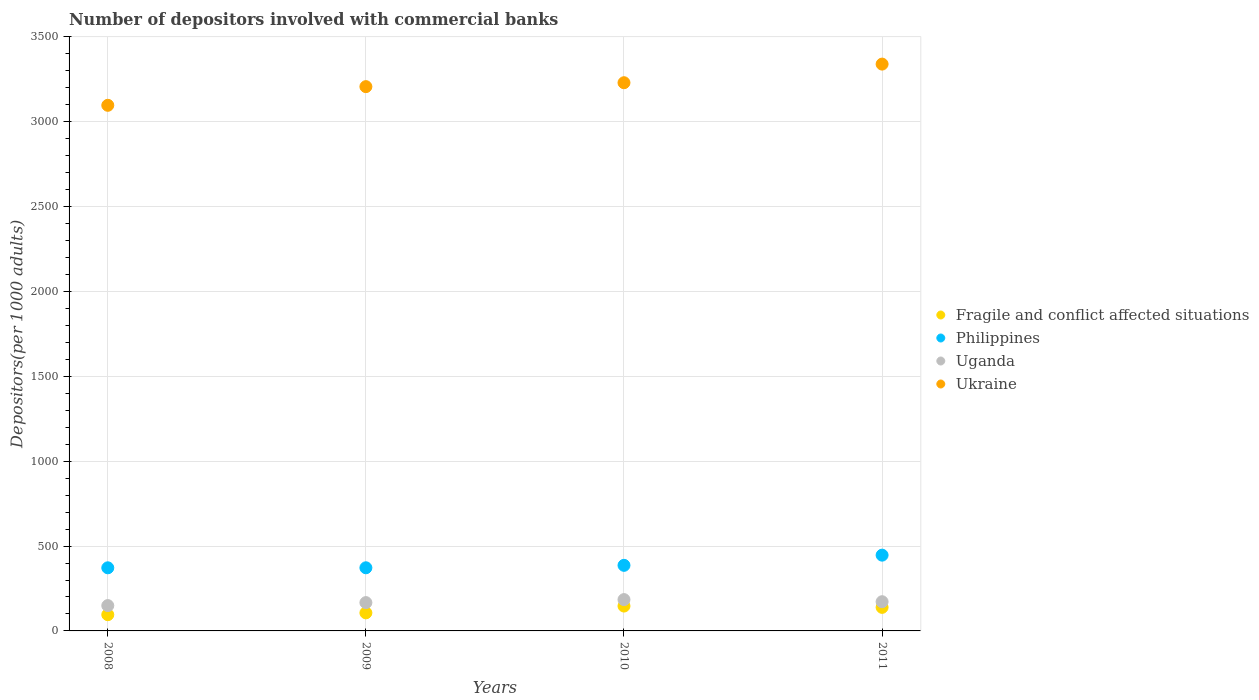How many different coloured dotlines are there?
Offer a terse response. 4. Is the number of dotlines equal to the number of legend labels?
Keep it short and to the point. Yes. What is the number of depositors involved with commercial banks in Philippines in 2010?
Make the answer very short. 386.38. Across all years, what is the maximum number of depositors involved with commercial banks in Fragile and conflict affected situations?
Keep it short and to the point. 146.5. Across all years, what is the minimum number of depositors involved with commercial banks in Uganda?
Offer a very short reply. 149.22. In which year was the number of depositors involved with commercial banks in Ukraine maximum?
Ensure brevity in your answer.  2011. What is the total number of depositors involved with commercial banks in Fragile and conflict affected situations in the graph?
Make the answer very short. 487.3. What is the difference between the number of depositors involved with commercial banks in Ukraine in 2008 and that in 2010?
Keep it short and to the point. -133.02. What is the difference between the number of depositors involved with commercial banks in Ukraine in 2011 and the number of depositors involved with commercial banks in Philippines in 2010?
Offer a terse response. 2953.02. What is the average number of depositors involved with commercial banks in Philippines per year?
Provide a succinct answer. 394.14. In the year 2010, what is the difference between the number of depositors involved with commercial banks in Uganda and number of depositors involved with commercial banks in Ukraine?
Ensure brevity in your answer.  -3045.11. What is the ratio of the number of depositors involved with commercial banks in Fragile and conflict affected situations in 2008 to that in 2011?
Ensure brevity in your answer.  0.69. What is the difference between the highest and the second highest number of depositors involved with commercial banks in Philippines?
Your answer should be very brief. 60.02. What is the difference between the highest and the lowest number of depositors involved with commercial banks in Fragile and conflict affected situations?
Your response must be concise. 50.84. In how many years, is the number of depositors involved with commercial banks in Fragile and conflict affected situations greater than the average number of depositors involved with commercial banks in Fragile and conflict affected situations taken over all years?
Your answer should be compact. 2. Is it the case that in every year, the sum of the number of depositors involved with commercial banks in Philippines and number of depositors involved with commercial banks in Uganda  is greater than the number of depositors involved with commercial banks in Fragile and conflict affected situations?
Provide a short and direct response. Yes. Is the number of depositors involved with commercial banks in Fragile and conflict affected situations strictly greater than the number of depositors involved with commercial banks in Philippines over the years?
Your response must be concise. No. How many dotlines are there?
Your answer should be very brief. 4. What is the difference between two consecutive major ticks on the Y-axis?
Offer a terse response. 500. Are the values on the major ticks of Y-axis written in scientific E-notation?
Your answer should be compact. No. Where does the legend appear in the graph?
Provide a succinct answer. Center right. What is the title of the graph?
Provide a succinct answer. Number of depositors involved with commercial banks. What is the label or title of the X-axis?
Offer a terse response. Years. What is the label or title of the Y-axis?
Give a very brief answer. Depositors(per 1000 adults). What is the Depositors(per 1000 adults) in Fragile and conflict affected situations in 2008?
Your answer should be compact. 95.65. What is the Depositors(per 1000 adults) of Philippines in 2008?
Provide a short and direct response. 371.81. What is the Depositors(per 1000 adults) in Uganda in 2008?
Give a very brief answer. 149.22. What is the Depositors(per 1000 adults) in Ukraine in 2008?
Offer a very short reply. 3096.67. What is the Depositors(per 1000 adults) in Fragile and conflict affected situations in 2009?
Your answer should be compact. 106.41. What is the Depositors(per 1000 adults) of Philippines in 2009?
Provide a short and direct response. 371.98. What is the Depositors(per 1000 adults) in Uganda in 2009?
Your answer should be compact. 166.83. What is the Depositors(per 1000 adults) in Ukraine in 2009?
Your response must be concise. 3206.64. What is the Depositors(per 1000 adults) of Fragile and conflict affected situations in 2010?
Your answer should be compact. 146.5. What is the Depositors(per 1000 adults) of Philippines in 2010?
Give a very brief answer. 386.38. What is the Depositors(per 1000 adults) in Uganda in 2010?
Offer a terse response. 184.58. What is the Depositors(per 1000 adults) of Ukraine in 2010?
Keep it short and to the point. 3229.69. What is the Depositors(per 1000 adults) in Fragile and conflict affected situations in 2011?
Offer a very short reply. 138.74. What is the Depositors(per 1000 adults) of Philippines in 2011?
Ensure brevity in your answer.  446.4. What is the Depositors(per 1000 adults) of Uganda in 2011?
Provide a succinct answer. 172.11. What is the Depositors(per 1000 adults) of Ukraine in 2011?
Provide a succinct answer. 3339.41. Across all years, what is the maximum Depositors(per 1000 adults) in Fragile and conflict affected situations?
Make the answer very short. 146.5. Across all years, what is the maximum Depositors(per 1000 adults) in Philippines?
Keep it short and to the point. 446.4. Across all years, what is the maximum Depositors(per 1000 adults) of Uganda?
Give a very brief answer. 184.58. Across all years, what is the maximum Depositors(per 1000 adults) of Ukraine?
Offer a terse response. 3339.41. Across all years, what is the minimum Depositors(per 1000 adults) in Fragile and conflict affected situations?
Your answer should be very brief. 95.65. Across all years, what is the minimum Depositors(per 1000 adults) of Philippines?
Offer a terse response. 371.81. Across all years, what is the minimum Depositors(per 1000 adults) in Uganda?
Provide a short and direct response. 149.22. Across all years, what is the minimum Depositors(per 1000 adults) in Ukraine?
Your answer should be very brief. 3096.67. What is the total Depositors(per 1000 adults) in Fragile and conflict affected situations in the graph?
Offer a terse response. 487.3. What is the total Depositors(per 1000 adults) of Philippines in the graph?
Keep it short and to the point. 1576.57. What is the total Depositors(per 1000 adults) in Uganda in the graph?
Your response must be concise. 672.74. What is the total Depositors(per 1000 adults) in Ukraine in the graph?
Your answer should be compact. 1.29e+04. What is the difference between the Depositors(per 1000 adults) of Fragile and conflict affected situations in 2008 and that in 2009?
Ensure brevity in your answer.  -10.75. What is the difference between the Depositors(per 1000 adults) of Philippines in 2008 and that in 2009?
Offer a very short reply. -0.17. What is the difference between the Depositors(per 1000 adults) in Uganda in 2008 and that in 2009?
Offer a very short reply. -17.61. What is the difference between the Depositors(per 1000 adults) of Ukraine in 2008 and that in 2009?
Your response must be concise. -109.97. What is the difference between the Depositors(per 1000 adults) in Fragile and conflict affected situations in 2008 and that in 2010?
Ensure brevity in your answer.  -50.84. What is the difference between the Depositors(per 1000 adults) of Philippines in 2008 and that in 2010?
Offer a terse response. -14.57. What is the difference between the Depositors(per 1000 adults) in Uganda in 2008 and that in 2010?
Provide a short and direct response. -35.36. What is the difference between the Depositors(per 1000 adults) of Ukraine in 2008 and that in 2010?
Your answer should be very brief. -133.02. What is the difference between the Depositors(per 1000 adults) in Fragile and conflict affected situations in 2008 and that in 2011?
Your answer should be very brief. -43.09. What is the difference between the Depositors(per 1000 adults) of Philippines in 2008 and that in 2011?
Keep it short and to the point. -74.59. What is the difference between the Depositors(per 1000 adults) in Uganda in 2008 and that in 2011?
Your response must be concise. -22.89. What is the difference between the Depositors(per 1000 adults) of Ukraine in 2008 and that in 2011?
Your answer should be very brief. -242.74. What is the difference between the Depositors(per 1000 adults) of Fragile and conflict affected situations in 2009 and that in 2010?
Your answer should be very brief. -40.09. What is the difference between the Depositors(per 1000 adults) of Philippines in 2009 and that in 2010?
Provide a short and direct response. -14.4. What is the difference between the Depositors(per 1000 adults) of Uganda in 2009 and that in 2010?
Offer a very short reply. -17.75. What is the difference between the Depositors(per 1000 adults) in Ukraine in 2009 and that in 2010?
Offer a very short reply. -23.06. What is the difference between the Depositors(per 1000 adults) of Fragile and conflict affected situations in 2009 and that in 2011?
Ensure brevity in your answer.  -32.34. What is the difference between the Depositors(per 1000 adults) in Philippines in 2009 and that in 2011?
Ensure brevity in your answer.  -74.42. What is the difference between the Depositors(per 1000 adults) in Uganda in 2009 and that in 2011?
Your response must be concise. -5.28. What is the difference between the Depositors(per 1000 adults) in Ukraine in 2009 and that in 2011?
Make the answer very short. -132.77. What is the difference between the Depositors(per 1000 adults) of Fragile and conflict affected situations in 2010 and that in 2011?
Offer a terse response. 7.75. What is the difference between the Depositors(per 1000 adults) in Philippines in 2010 and that in 2011?
Offer a terse response. -60.02. What is the difference between the Depositors(per 1000 adults) of Uganda in 2010 and that in 2011?
Offer a terse response. 12.47. What is the difference between the Depositors(per 1000 adults) of Ukraine in 2010 and that in 2011?
Give a very brief answer. -109.71. What is the difference between the Depositors(per 1000 adults) of Fragile and conflict affected situations in 2008 and the Depositors(per 1000 adults) of Philippines in 2009?
Ensure brevity in your answer.  -276.33. What is the difference between the Depositors(per 1000 adults) in Fragile and conflict affected situations in 2008 and the Depositors(per 1000 adults) in Uganda in 2009?
Give a very brief answer. -71.18. What is the difference between the Depositors(per 1000 adults) in Fragile and conflict affected situations in 2008 and the Depositors(per 1000 adults) in Ukraine in 2009?
Provide a succinct answer. -3110.99. What is the difference between the Depositors(per 1000 adults) of Philippines in 2008 and the Depositors(per 1000 adults) of Uganda in 2009?
Keep it short and to the point. 204.98. What is the difference between the Depositors(per 1000 adults) of Philippines in 2008 and the Depositors(per 1000 adults) of Ukraine in 2009?
Make the answer very short. -2834.83. What is the difference between the Depositors(per 1000 adults) in Uganda in 2008 and the Depositors(per 1000 adults) in Ukraine in 2009?
Provide a succinct answer. -3057.42. What is the difference between the Depositors(per 1000 adults) of Fragile and conflict affected situations in 2008 and the Depositors(per 1000 adults) of Philippines in 2010?
Offer a terse response. -290.73. What is the difference between the Depositors(per 1000 adults) of Fragile and conflict affected situations in 2008 and the Depositors(per 1000 adults) of Uganda in 2010?
Offer a terse response. -88.93. What is the difference between the Depositors(per 1000 adults) in Fragile and conflict affected situations in 2008 and the Depositors(per 1000 adults) in Ukraine in 2010?
Keep it short and to the point. -3134.04. What is the difference between the Depositors(per 1000 adults) in Philippines in 2008 and the Depositors(per 1000 adults) in Uganda in 2010?
Make the answer very short. 187.23. What is the difference between the Depositors(per 1000 adults) in Philippines in 2008 and the Depositors(per 1000 adults) in Ukraine in 2010?
Provide a short and direct response. -2857.88. What is the difference between the Depositors(per 1000 adults) of Uganda in 2008 and the Depositors(per 1000 adults) of Ukraine in 2010?
Your answer should be compact. -3080.47. What is the difference between the Depositors(per 1000 adults) in Fragile and conflict affected situations in 2008 and the Depositors(per 1000 adults) in Philippines in 2011?
Make the answer very short. -350.75. What is the difference between the Depositors(per 1000 adults) of Fragile and conflict affected situations in 2008 and the Depositors(per 1000 adults) of Uganda in 2011?
Your answer should be very brief. -76.45. What is the difference between the Depositors(per 1000 adults) in Fragile and conflict affected situations in 2008 and the Depositors(per 1000 adults) in Ukraine in 2011?
Give a very brief answer. -3243.75. What is the difference between the Depositors(per 1000 adults) of Philippines in 2008 and the Depositors(per 1000 adults) of Uganda in 2011?
Your answer should be compact. 199.7. What is the difference between the Depositors(per 1000 adults) of Philippines in 2008 and the Depositors(per 1000 adults) of Ukraine in 2011?
Offer a terse response. -2967.59. What is the difference between the Depositors(per 1000 adults) of Uganda in 2008 and the Depositors(per 1000 adults) of Ukraine in 2011?
Provide a succinct answer. -3190.19. What is the difference between the Depositors(per 1000 adults) of Fragile and conflict affected situations in 2009 and the Depositors(per 1000 adults) of Philippines in 2010?
Provide a short and direct response. -279.98. What is the difference between the Depositors(per 1000 adults) of Fragile and conflict affected situations in 2009 and the Depositors(per 1000 adults) of Uganda in 2010?
Your response must be concise. -78.17. What is the difference between the Depositors(per 1000 adults) in Fragile and conflict affected situations in 2009 and the Depositors(per 1000 adults) in Ukraine in 2010?
Provide a succinct answer. -3123.29. What is the difference between the Depositors(per 1000 adults) of Philippines in 2009 and the Depositors(per 1000 adults) of Uganda in 2010?
Ensure brevity in your answer.  187.4. What is the difference between the Depositors(per 1000 adults) of Philippines in 2009 and the Depositors(per 1000 adults) of Ukraine in 2010?
Make the answer very short. -2857.71. What is the difference between the Depositors(per 1000 adults) of Uganda in 2009 and the Depositors(per 1000 adults) of Ukraine in 2010?
Provide a succinct answer. -3062.86. What is the difference between the Depositors(per 1000 adults) of Fragile and conflict affected situations in 2009 and the Depositors(per 1000 adults) of Philippines in 2011?
Keep it short and to the point. -339.99. What is the difference between the Depositors(per 1000 adults) of Fragile and conflict affected situations in 2009 and the Depositors(per 1000 adults) of Uganda in 2011?
Offer a very short reply. -65.7. What is the difference between the Depositors(per 1000 adults) of Fragile and conflict affected situations in 2009 and the Depositors(per 1000 adults) of Ukraine in 2011?
Make the answer very short. -3233. What is the difference between the Depositors(per 1000 adults) in Philippines in 2009 and the Depositors(per 1000 adults) in Uganda in 2011?
Provide a succinct answer. 199.87. What is the difference between the Depositors(per 1000 adults) of Philippines in 2009 and the Depositors(per 1000 adults) of Ukraine in 2011?
Give a very brief answer. -2967.43. What is the difference between the Depositors(per 1000 adults) in Uganda in 2009 and the Depositors(per 1000 adults) in Ukraine in 2011?
Provide a short and direct response. -3172.58. What is the difference between the Depositors(per 1000 adults) of Fragile and conflict affected situations in 2010 and the Depositors(per 1000 adults) of Philippines in 2011?
Your answer should be very brief. -299.9. What is the difference between the Depositors(per 1000 adults) in Fragile and conflict affected situations in 2010 and the Depositors(per 1000 adults) in Uganda in 2011?
Ensure brevity in your answer.  -25.61. What is the difference between the Depositors(per 1000 adults) of Fragile and conflict affected situations in 2010 and the Depositors(per 1000 adults) of Ukraine in 2011?
Offer a terse response. -3192.91. What is the difference between the Depositors(per 1000 adults) in Philippines in 2010 and the Depositors(per 1000 adults) in Uganda in 2011?
Offer a terse response. 214.28. What is the difference between the Depositors(per 1000 adults) of Philippines in 2010 and the Depositors(per 1000 adults) of Ukraine in 2011?
Make the answer very short. -2953.02. What is the difference between the Depositors(per 1000 adults) of Uganda in 2010 and the Depositors(per 1000 adults) of Ukraine in 2011?
Provide a succinct answer. -3154.83. What is the average Depositors(per 1000 adults) in Fragile and conflict affected situations per year?
Provide a short and direct response. 121.82. What is the average Depositors(per 1000 adults) of Philippines per year?
Your answer should be very brief. 394.14. What is the average Depositors(per 1000 adults) of Uganda per year?
Your answer should be compact. 168.18. What is the average Depositors(per 1000 adults) of Ukraine per year?
Your answer should be compact. 3218.1. In the year 2008, what is the difference between the Depositors(per 1000 adults) in Fragile and conflict affected situations and Depositors(per 1000 adults) in Philippines?
Offer a very short reply. -276.16. In the year 2008, what is the difference between the Depositors(per 1000 adults) in Fragile and conflict affected situations and Depositors(per 1000 adults) in Uganda?
Offer a very short reply. -53.57. In the year 2008, what is the difference between the Depositors(per 1000 adults) in Fragile and conflict affected situations and Depositors(per 1000 adults) in Ukraine?
Ensure brevity in your answer.  -3001.02. In the year 2008, what is the difference between the Depositors(per 1000 adults) of Philippines and Depositors(per 1000 adults) of Uganda?
Your response must be concise. 222.59. In the year 2008, what is the difference between the Depositors(per 1000 adults) of Philippines and Depositors(per 1000 adults) of Ukraine?
Give a very brief answer. -2724.86. In the year 2008, what is the difference between the Depositors(per 1000 adults) in Uganda and Depositors(per 1000 adults) in Ukraine?
Provide a succinct answer. -2947.45. In the year 2009, what is the difference between the Depositors(per 1000 adults) in Fragile and conflict affected situations and Depositors(per 1000 adults) in Philippines?
Make the answer very short. -265.57. In the year 2009, what is the difference between the Depositors(per 1000 adults) in Fragile and conflict affected situations and Depositors(per 1000 adults) in Uganda?
Your answer should be compact. -60.42. In the year 2009, what is the difference between the Depositors(per 1000 adults) of Fragile and conflict affected situations and Depositors(per 1000 adults) of Ukraine?
Make the answer very short. -3100.23. In the year 2009, what is the difference between the Depositors(per 1000 adults) of Philippines and Depositors(per 1000 adults) of Uganda?
Give a very brief answer. 205.15. In the year 2009, what is the difference between the Depositors(per 1000 adults) of Philippines and Depositors(per 1000 adults) of Ukraine?
Offer a terse response. -2834.66. In the year 2009, what is the difference between the Depositors(per 1000 adults) of Uganda and Depositors(per 1000 adults) of Ukraine?
Give a very brief answer. -3039.81. In the year 2010, what is the difference between the Depositors(per 1000 adults) in Fragile and conflict affected situations and Depositors(per 1000 adults) in Philippines?
Your answer should be compact. -239.89. In the year 2010, what is the difference between the Depositors(per 1000 adults) in Fragile and conflict affected situations and Depositors(per 1000 adults) in Uganda?
Ensure brevity in your answer.  -38.08. In the year 2010, what is the difference between the Depositors(per 1000 adults) in Fragile and conflict affected situations and Depositors(per 1000 adults) in Ukraine?
Your response must be concise. -3083.2. In the year 2010, what is the difference between the Depositors(per 1000 adults) in Philippines and Depositors(per 1000 adults) in Uganda?
Your answer should be compact. 201.8. In the year 2010, what is the difference between the Depositors(per 1000 adults) of Philippines and Depositors(per 1000 adults) of Ukraine?
Give a very brief answer. -2843.31. In the year 2010, what is the difference between the Depositors(per 1000 adults) of Uganda and Depositors(per 1000 adults) of Ukraine?
Make the answer very short. -3045.11. In the year 2011, what is the difference between the Depositors(per 1000 adults) in Fragile and conflict affected situations and Depositors(per 1000 adults) in Philippines?
Provide a succinct answer. -307.66. In the year 2011, what is the difference between the Depositors(per 1000 adults) in Fragile and conflict affected situations and Depositors(per 1000 adults) in Uganda?
Your answer should be very brief. -33.36. In the year 2011, what is the difference between the Depositors(per 1000 adults) of Fragile and conflict affected situations and Depositors(per 1000 adults) of Ukraine?
Keep it short and to the point. -3200.66. In the year 2011, what is the difference between the Depositors(per 1000 adults) of Philippines and Depositors(per 1000 adults) of Uganda?
Ensure brevity in your answer.  274.29. In the year 2011, what is the difference between the Depositors(per 1000 adults) in Philippines and Depositors(per 1000 adults) in Ukraine?
Your response must be concise. -2893.01. In the year 2011, what is the difference between the Depositors(per 1000 adults) in Uganda and Depositors(per 1000 adults) in Ukraine?
Your answer should be very brief. -3167.3. What is the ratio of the Depositors(per 1000 adults) in Fragile and conflict affected situations in 2008 to that in 2009?
Ensure brevity in your answer.  0.9. What is the ratio of the Depositors(per 1000 adults) in Philippines in 2008 to that in 2009?
Give a very brief answer. 1. What is the ratio of the Depositors(per 1000 adults) of Uganda in 2008 to that in 2009?
Offer a terse response. 0.89. What is the ratio of the Depositors(per 1000 adults) of Ukraine in 2008 to that in 2009?
Your response must be concise. 0.97. What is the ratio of the Depositors(per 1000 adults) in Fragile and conflict affected situations in 2008 to that in 2010?
Keep it short and to the point. 0.65. What is the ratio of the Depositors(per 1000 adults) in Philippines in 2008 to that in 2010?
Your answer should be very brief. 0.96. What is the ratio of the Depositors(per 1000 adults) in Uganda in 2008 to that in 2010?
Keep it short and to the point. 0.81. What is the ratio of the Depositors(per 1000 adults) of Ukraine in 2008 to that in 2010?
Your response must be concise. 0.96. What is the ratio of the Depositors(per 1000 adults) in Fragile and conflict affected situations in 2008 to that in 2011?
Keep it short and to the point. 0.69. What is the ratio of the Depositors(per 1000 adults) in Philippines in 2008 to that in 2011?
Your response must be concise. 0.83. What is the ratio of the Depositors(per 1000 adults) of Uganda in 2008 to that in 2011?
Ensure brevity in your answer.  0.87. What is the ratio of the Depositors(per 1000 adults) of Ukraine in 2008 to that in 2011?
Make the answer very short. 0.93. What is the ratio of the Depositors(per 1000 adults) in Fragile and conflict affected situations in 2009 to that in 2010?
Provide a short and direct response. 0.73. What is the ratio of the Depositors(per 1000 adults) of Philippines in 2009 to that in 2010?
Keep it short and to the point. 0.96. What is the ratio of the Depositors(per 1000 adults) in Uganda in 2009 to that in 2010?
Your response must be concise. 0.9. What is the ratio of the Depositors(per 1000 adults) in Fragile and conflict affected situations in 2009 to that in 2011?
Offer a terse response. 0.77. What is the ratio of the Depositors(per 1000 adults) in Philippines in 2009 to that in 2011?
Provide a short and direct response. 0.83. What is the ratio of the Depositors(per 1000 adults) of Uganda in 2009 to that in 2011?
Offer a very short reply. 0.97. What is the ratio of the Depositors(per 1000 adults) in Ukraine in 2009 to that in 2011?
Offer a terse response. 0.96. What is the ratio of the Depositors(per 1000 adults) in Fragile and conflict affected situations in 2010 to that in 2011?
Your answer should be very brief. 1.06. What is the ratio of the Depositors(per 1000 adults) in Philippines in 2010 to that in 2011?
Your answer should be very brief. 0.87. What is the ratio of the Depositors(per 1000 adults) of Uganda in 2010 to that in 2011?
Offer a terse response. 1.07. What is the ratio of the Depositors(per 1000 adults) in Ukraine in 2010 to that in 2011?
Offer a terse response. 0.97. What is the difference between the highest and the second highest Depositors(per 1000 adults) in Fragile and conflict affected situations?
Offer a very short reply. 7.75. What is the difference between the highest and the second highest Depositors(per 1000 adults) of Philippines?
Give a very brief answer. 60.02. What is the difference between the highest and the second highest Depositors(per 1000 adults) of Uganda?
Provide a short and direct response. 12.47. What is the difference between the highest and the second highest Depositors(per 1000 adults) of Ukraine?
Provide a short and direct response. 109.71. What is the difference between the highest and the lowest Depositors(per 1000 adults) in Fragile and conflict affected situations?
Keep it short and to the point. 50.84. What is the difference between the highest and the lowest Depositors(per 1000 adults) in Philippines?
Offer a very short reply. 74.59. What is the difference between the highest and the lowest Depositors(per 1000 adults) of Uganda?
Offer a terse response. 35.36. What is the difference between the highest and the lowest Depositors(per 1000 adults) in Ukraine?
Offer a terse response. 242.74. 